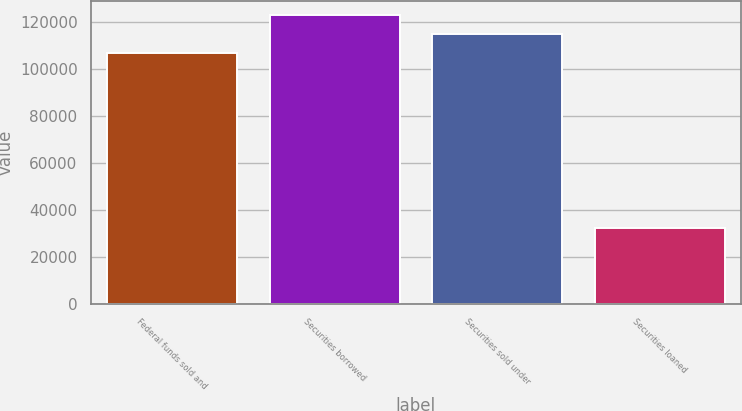Convert chart. <chart><loc_0><loc_0><loc_500><loc_500><bar_chart><fcel>Federal funds sold and<fcel>Securities borrowed<fcel>Securities sold under<fcel>Securities loaned<nl><fcel>106828<fcel>122987<fcel>114908<fcel>32543<nl></chart> 